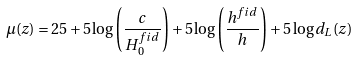<formula> <loc_0><loc_0><loc_500><loc_500>\mu ( z ) = 2 5 + 5 \log { \left ( \frac { c } { H _ { 0 } ^ { f i d } } \right ) } + 5 \log { \left ( \frac { h ^ { f i d } } { h } \right ) } + 5 \log { d _ { L } ( z ) }</formula> 